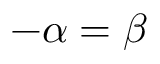<formula> <loc_0><loc_0><loc_500><loc_500>- \alpha = \beta</formula> 